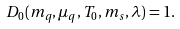<formula> <loc_0><loc_0><loc_500><loc_500>D _ { 0 } ( m _ { q } , \mu _ { q } , T _ { 0 } , m _ { s } , \lambda ) = 1 .</formula> 